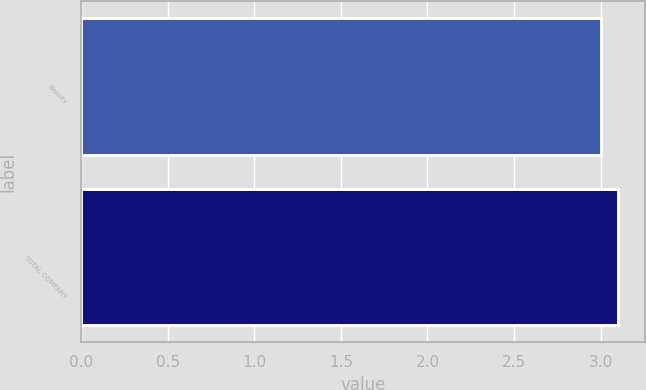Convert chart to OTSL. <chart><loc_0><loc_0><loc_500><loc_500><bar_chart><fcel>Beauty<fcel>TOTAL COMPANY<nl><fcel>3<fcel>3.1<nl></chart> 